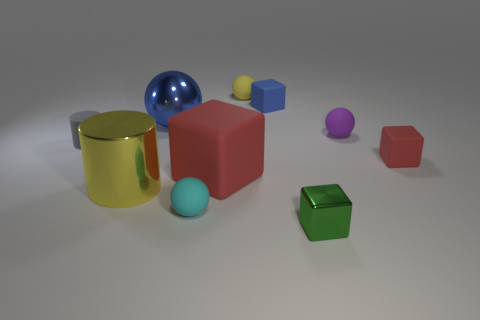Subtract all shiny blocks. How many blocks are left? 3 Subtract all green cylinders. How many red blocks are left? 2 Subtract 2 balls. How many balls are left? 2 Subtract all cubes. How many objects are left? 6 Subtract all yellow balls. How many balls are left? 3 Subtract 1 gray cylinders. How many objects are left? 9 Subtract all gray cylinders. Subtract all brown blocks. How many cylinders are left? 1 Subtract all tiny red rubber objects. Subtract all tiny blue rubber cubes. How many objects are left? 8 Add 3 small green things. How many small green things are left? 4 Add 2 small matte spheres. How many small matte spheres exist? 5 